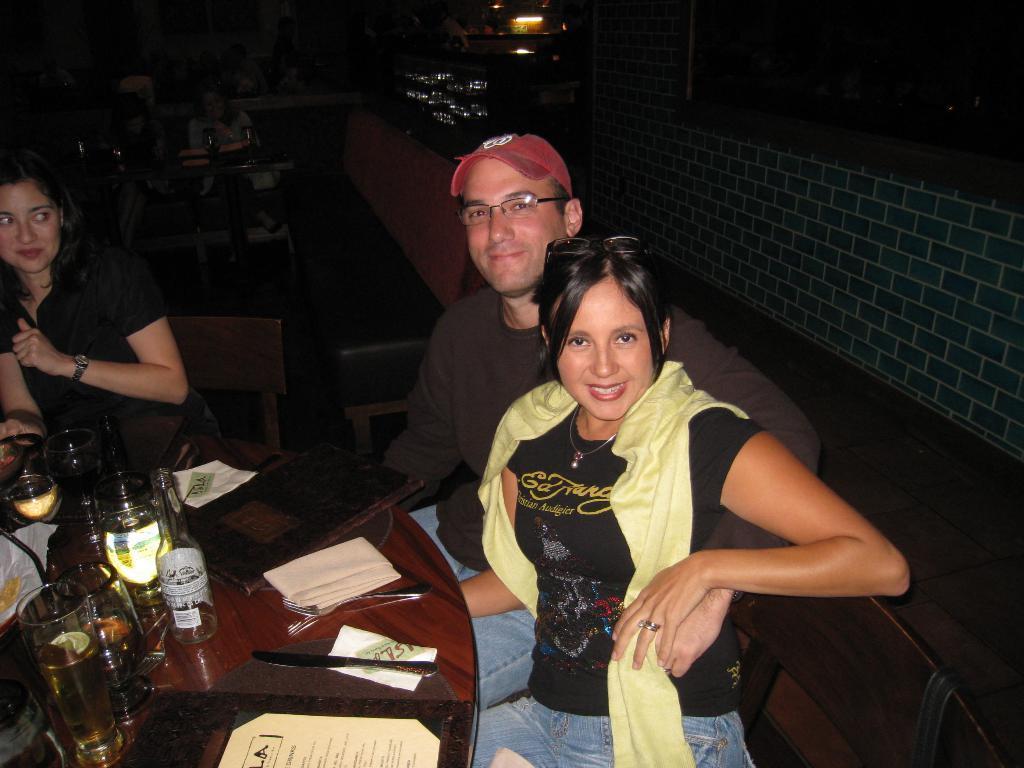In one or two sentences, can you explain what this image depicts? It is a restaurant , three people are sitting around the table two are women and one man, there are glasses, bottles,a menu card,tissues, fork and knife on the table, behind these people there are another people who are sitting around , in the background we can see a brick wall blue color beside that wall there are some glasses and lights. 